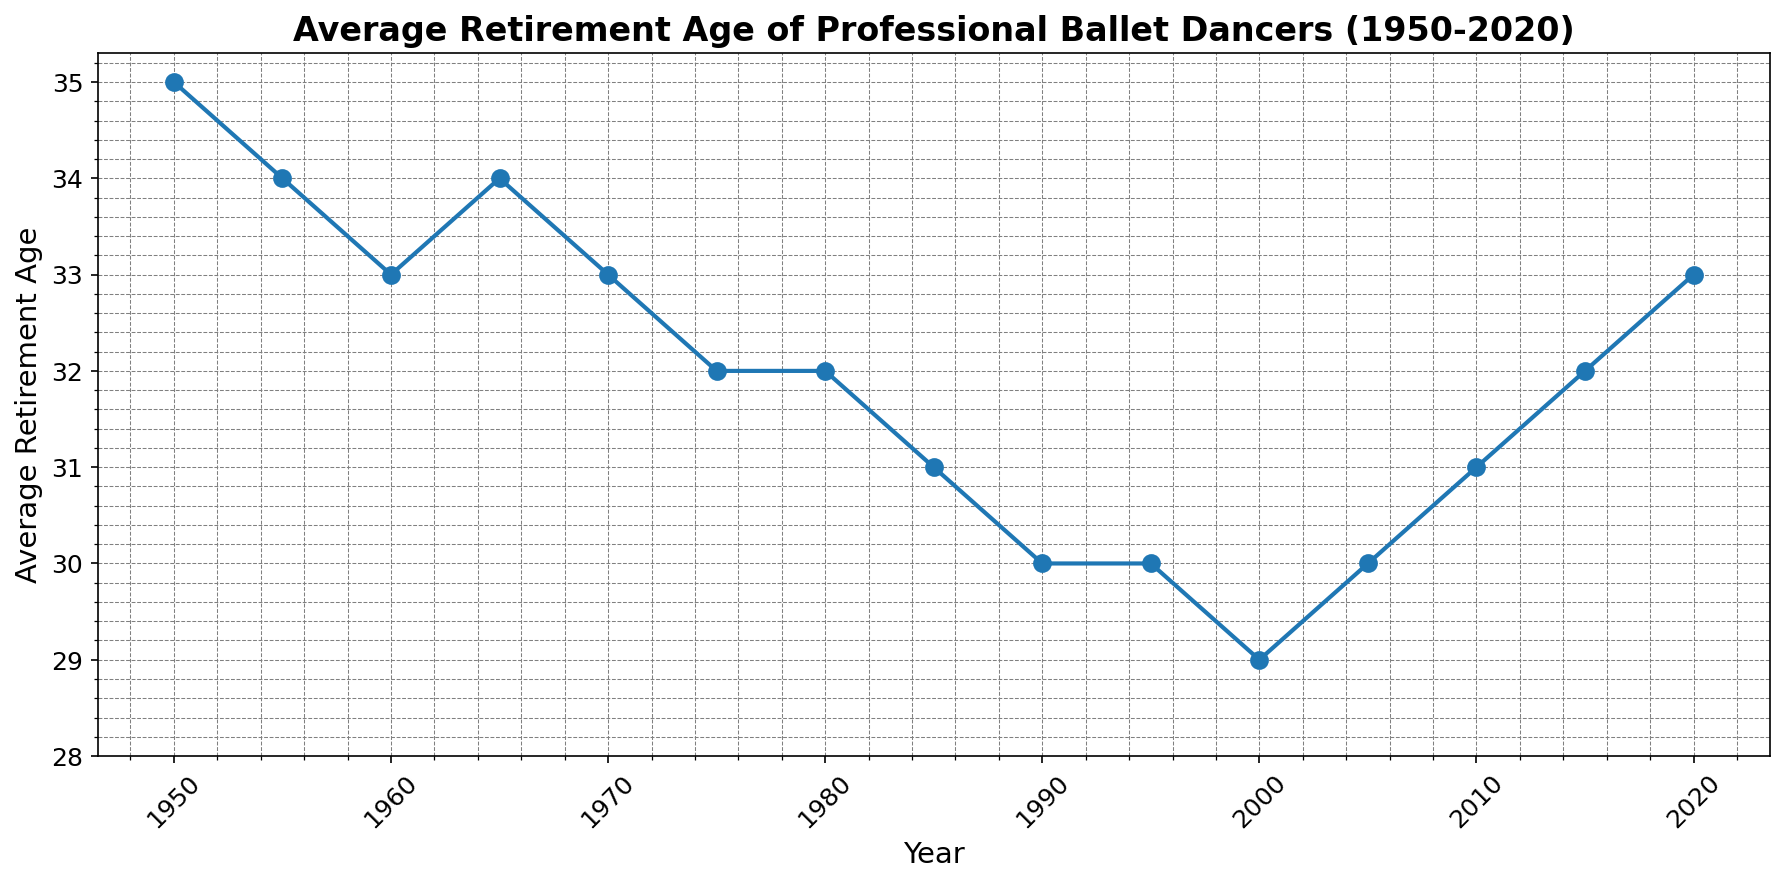What is the average retirement age of ballet dancers in 1950? Look at the data point in the year 1950 and see the corresponding value on the y-axis.
Answer: 35 How did the average retirement age of ballet dancers change from 1950 to 1985? Compare the retirement age values in 1950 and 1985. The value in 1950 is 35 and in 1985 is 31, which means a decrease of 4 years.
Answer: Decreased by 4 years Between which years did the average retirement age of ballet dancers reach its lowest point? Identify the lowest value on the y-axis, which is 29, marked in the year 2000. Then check the surrounding years to ensure no lower values exist.
Answer: 2000 What is the difference in average retirement age between 1970 and 2020? Find the retirement age values for 1970 and 2020, which are 33 and 33 respectively. Calculate the difference: 33 - 33.
Answer: 0 From 2000 to 2020, did the average retirement age of ballet dancers show an increasing or decreasing trend? Observe the trend line from 2000 (retirement age 29) to 2020 (retirement age 33). The trend is upward.
Answer: Increasing How many years did the average retirement age remain below 32? Count the years where the y-axis value is below 32. These are 1980, 1985, 1990, 1995, and 2000, making a total of 5 years.
Answer: 5 years What is the average retirement age of ballet dancers during the 1970s? Find the retirement age values for the years 1970, 1975, and 1980, which are 33, 32, and 32 respectively. Calculate the average: (33 + 32 + 32) / 3.
Answer: 32.33 Which decade saw the biggest decrease in average retirement age? Compare the retirement ages for each decade. The 1970s saw a decrease from 34 in 1965 to 32 in 1980, which is a change of 2.
Answer: 1970s What is the average trend in retirement age from 2010 to 2020? Calculate the average of values in 2010, 2015, and 2020, which are 31, 32, and 33 respectively. This indicates an upward trend.
Answer: Upward What is the general trend of average retirement age from 1950 to 2000? Summarize the pattern in the plot from 1950 to 2000. Most of the earlier years show higher values which then gradually decrease by 2000.
Answer: Decreasing 